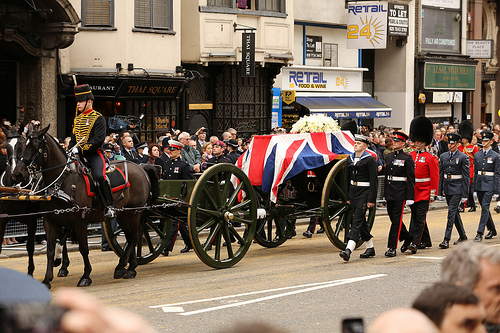Which kind of vehicle is pulled by the horse? The horse is pulling a wagon. 